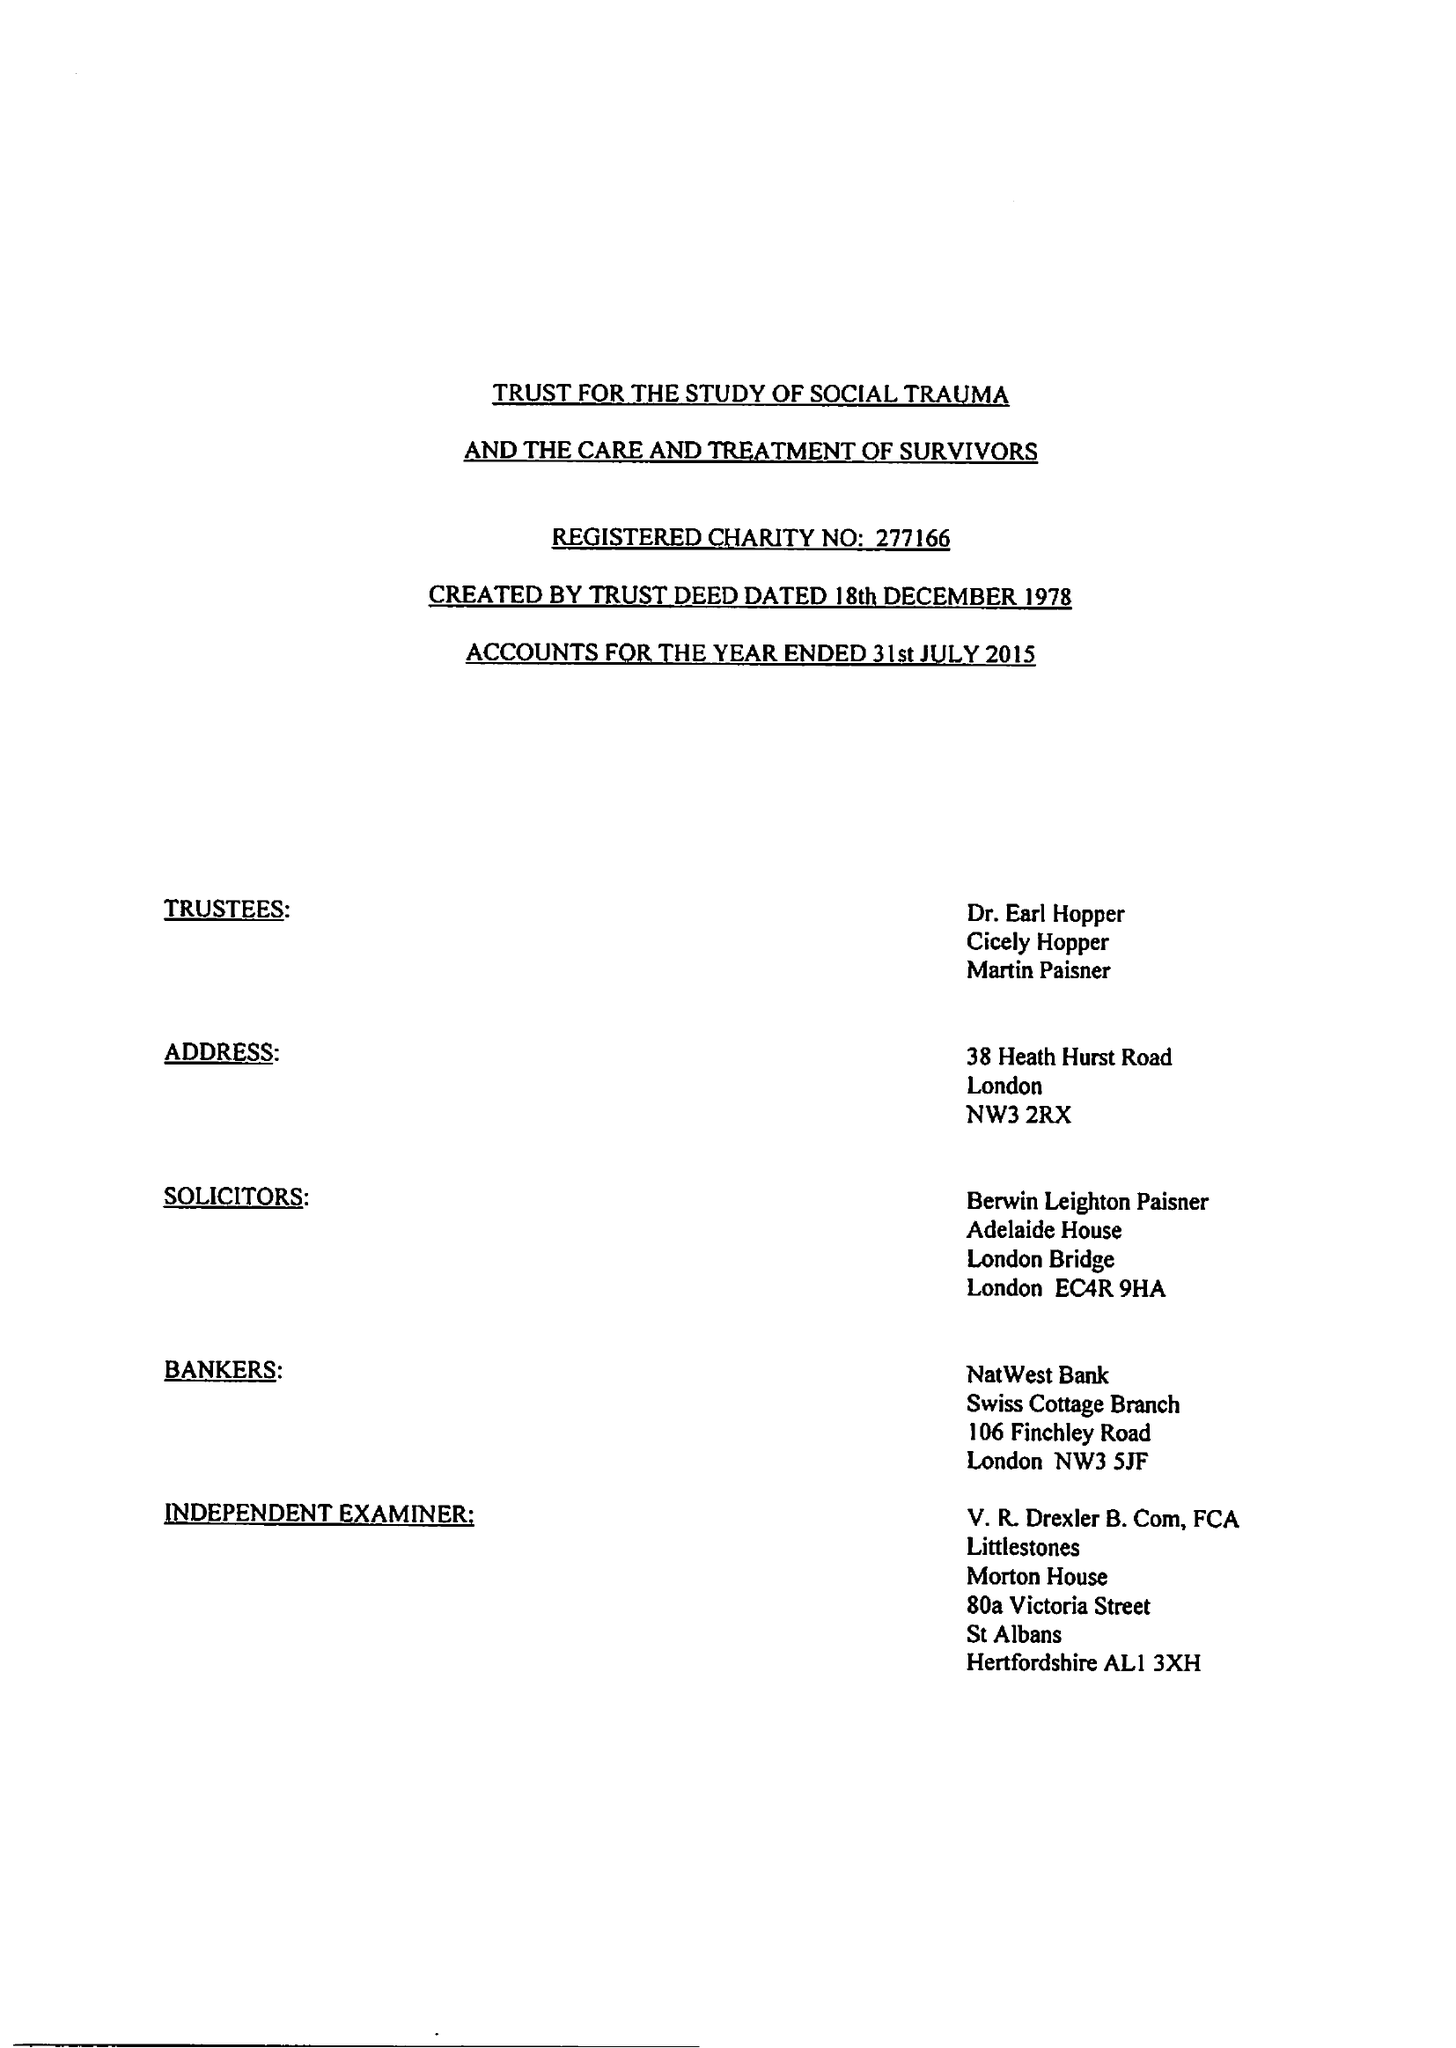What is the value for the charity_number?
Answer the question using a single word or phrase. 277166 